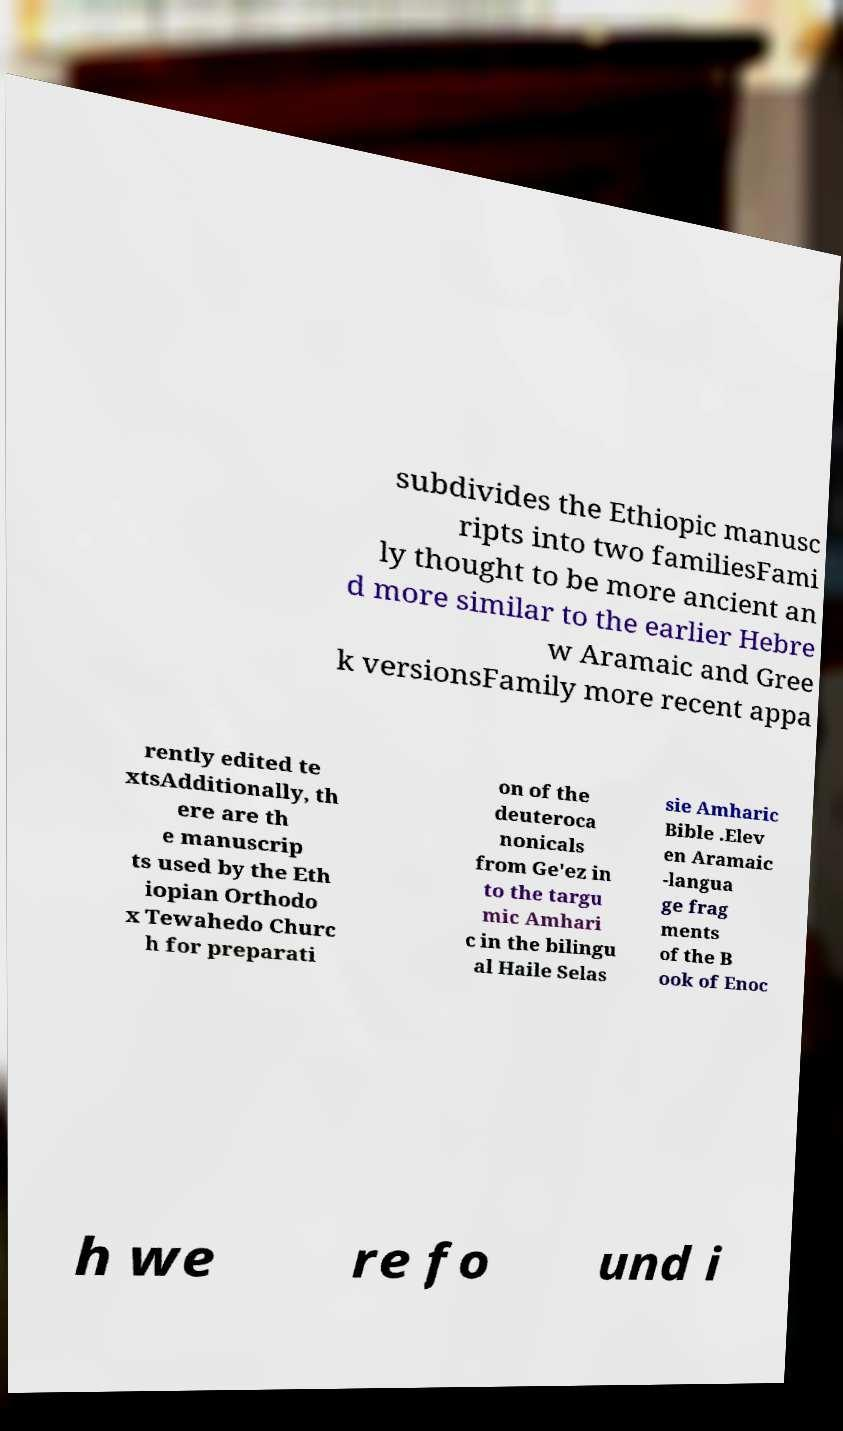Could you extract and type out the text from this image? subdivides the Ethiopic manusc ripts into two familiesFami ly thought to be more ancient an d more similar to the earlier Hebre w Aramaic and Gree k versionsFamily more recent appa rently edited te xtsAdditionally, th ere are th e manuscrip ts used by the Eth iopian Orthodo x Tewahedo Churc h for preparati on of the deuteroca nonicals from Ge'ez in to the targu mic Amhari c in the bilingu al Haile Selas sie Amharic Bible .Elev en Aramaic -langua ge frag ments of the B ook of Enoc h we re fo und i 